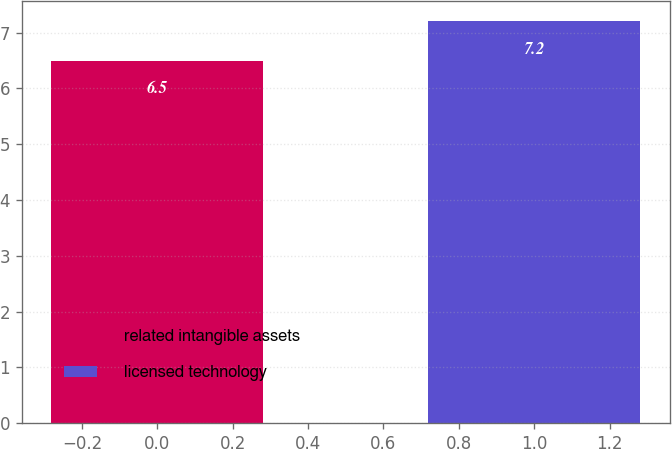Convert chart. <chart><loc_0><loc_0><loc_500><loc_500><bar_chart><fcel>related intangible assets<fcel>licensed technology<nl><fcel>6.5<fcel>7.2<nl></chart> 